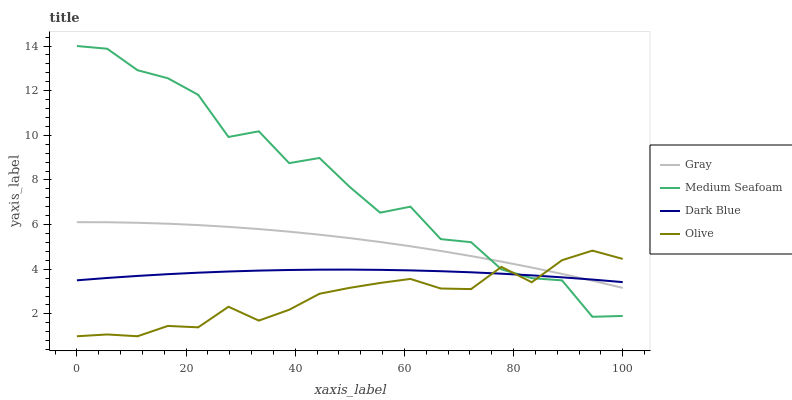Does Olive have the minimum area under the curve?
Answer yes or no. Yes. Does Medium Seafoam have the maximum area under the curve?
Answer yes or no. Yes. Does Gray have the minimum area under the curve?
Answer yes or no. No. Does Gray have the maximum area under the curve?
Answer yes or no. No. Is Dark Blue the smoothest?
Answer yes or no. Yes. Is Medium Seafoam the roughest?
Answer yes or no. Yes. Is Gray the smoothest?
Answer yes or no. No. Is Gray the roughest?
Answer yes or no. No. Does Gray have the lowest value?
Answer yes or no. No. Does Medium Seafoam have the highest value?
Answer yes or no. Yes. Does Gray have the highest value?
Answer yes or no. No. Does Medium Seafoam intersect Olive?
Answer yes or no. Yes. Is Medium Seafoam less than Olive?
Answer yes or no. No. Is Medium Seafoam greater than Olive?
Answer yes or no. No. 